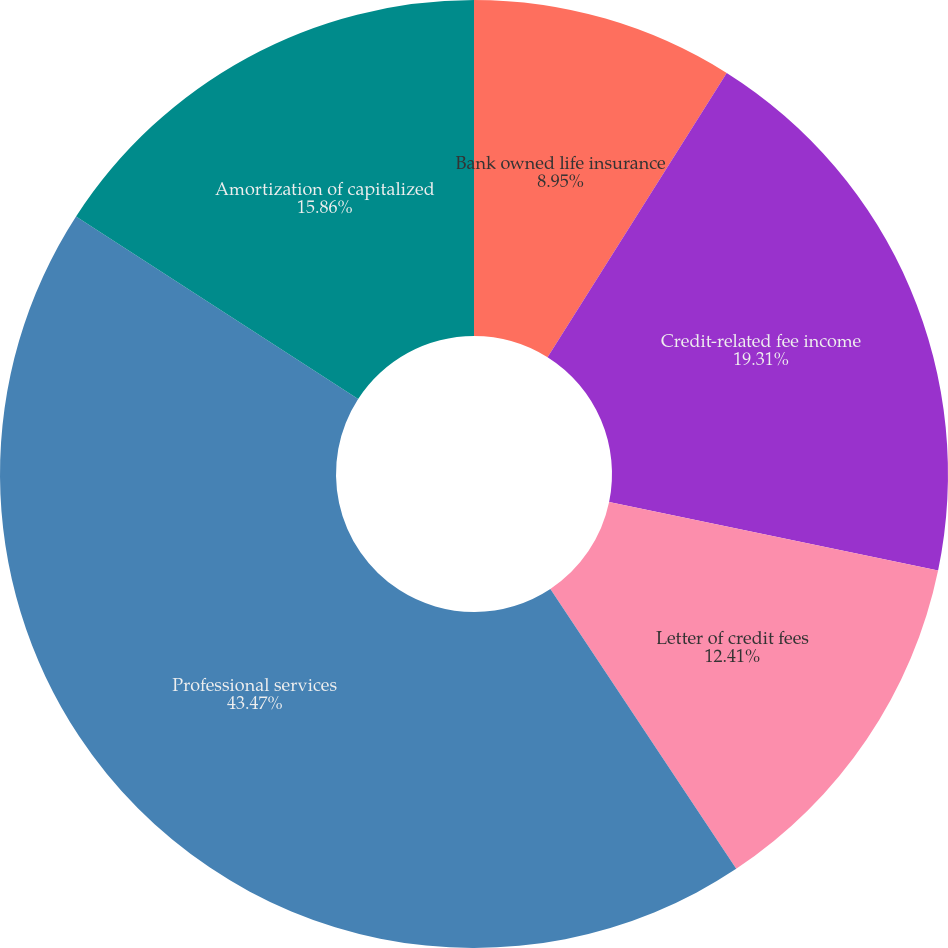<chart> <loc_0><loc_0><loc_500><loc_500><pie_chart><fcel>Bank owned life insurance<fcel>Credit-related fee income<fcel>Letter of credit fees<fcel>Professional services<fcel>Amortization of capitalized<nl><fcel>8.95%<fcel>19.31%<fcel>12.41%<fcel>43.47%<fcel>15.86%<nl></chart> 